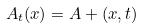<formula> <loc_0><loc_0><loc_500><loc_500>A _ { t } ( x ) = A + ( x , t )</formula> 